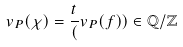Convert formula to latex. <formula><loc_0><loc_0><loc_500><loc_500>v _ { P } ( \chi ) = \frac { t } { ( } v _ { P } ( f ) ) \in \mathbb { Q } / \mathbb { Z }</formula> 